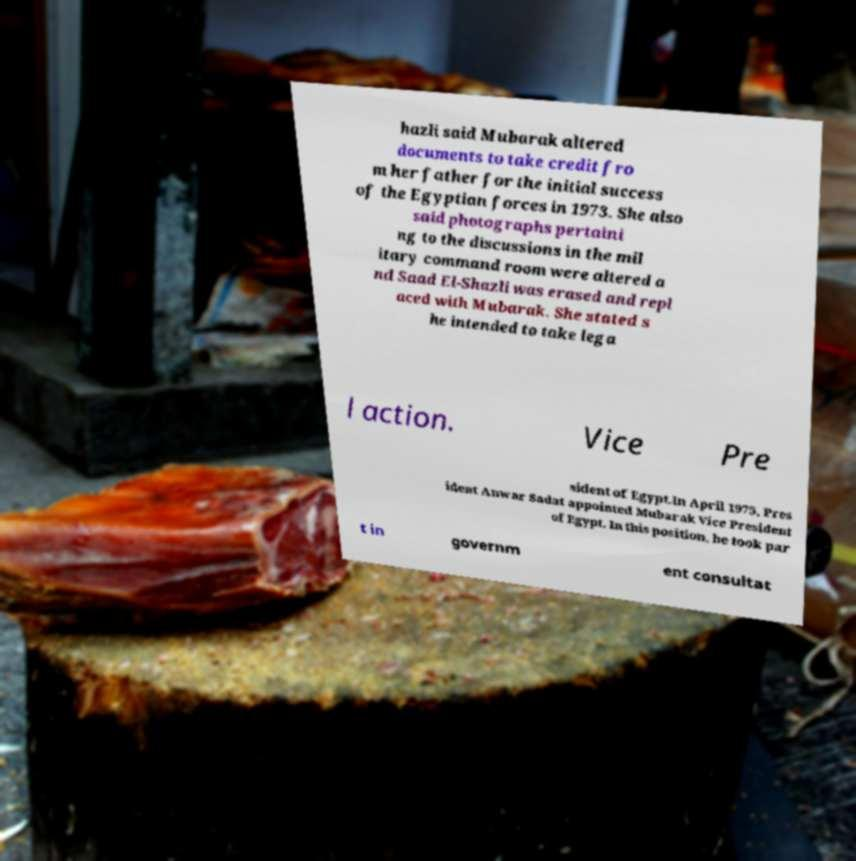Could you extract and type out the text from this image? hazli said Mubarak altered documents to take credit fro m her father for the initial success of the Egyptian forces in 1973. She also said photographs pertaini ng to the discussions in the mil itary command room were altered a nd Saad El-Shazli was erased and repl aced with Mubarak. She stated s he intended to take lega l action. Vice Pre sident of Egypt.In April 1975, Pres ident Anwar Sadat appointed Mubarak Vice President of Egypt. In this position, he took par t in governm ent consultat 